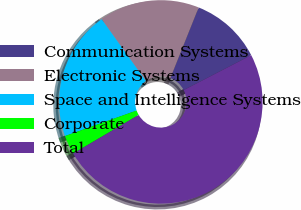<chart> <loc_0><loc_0><loc_500><loc_500><pie_chart><fcel>Communication Systems<fcel>Electronic Systems<fcel>Space and Intelligence Systems<fcel>Corporate<fcel>Total<nl><fcel>11.34%<fcel>15.95%<fcel>20.56%<fcel>3.02%<fcel>49.13%<nl></chart> 